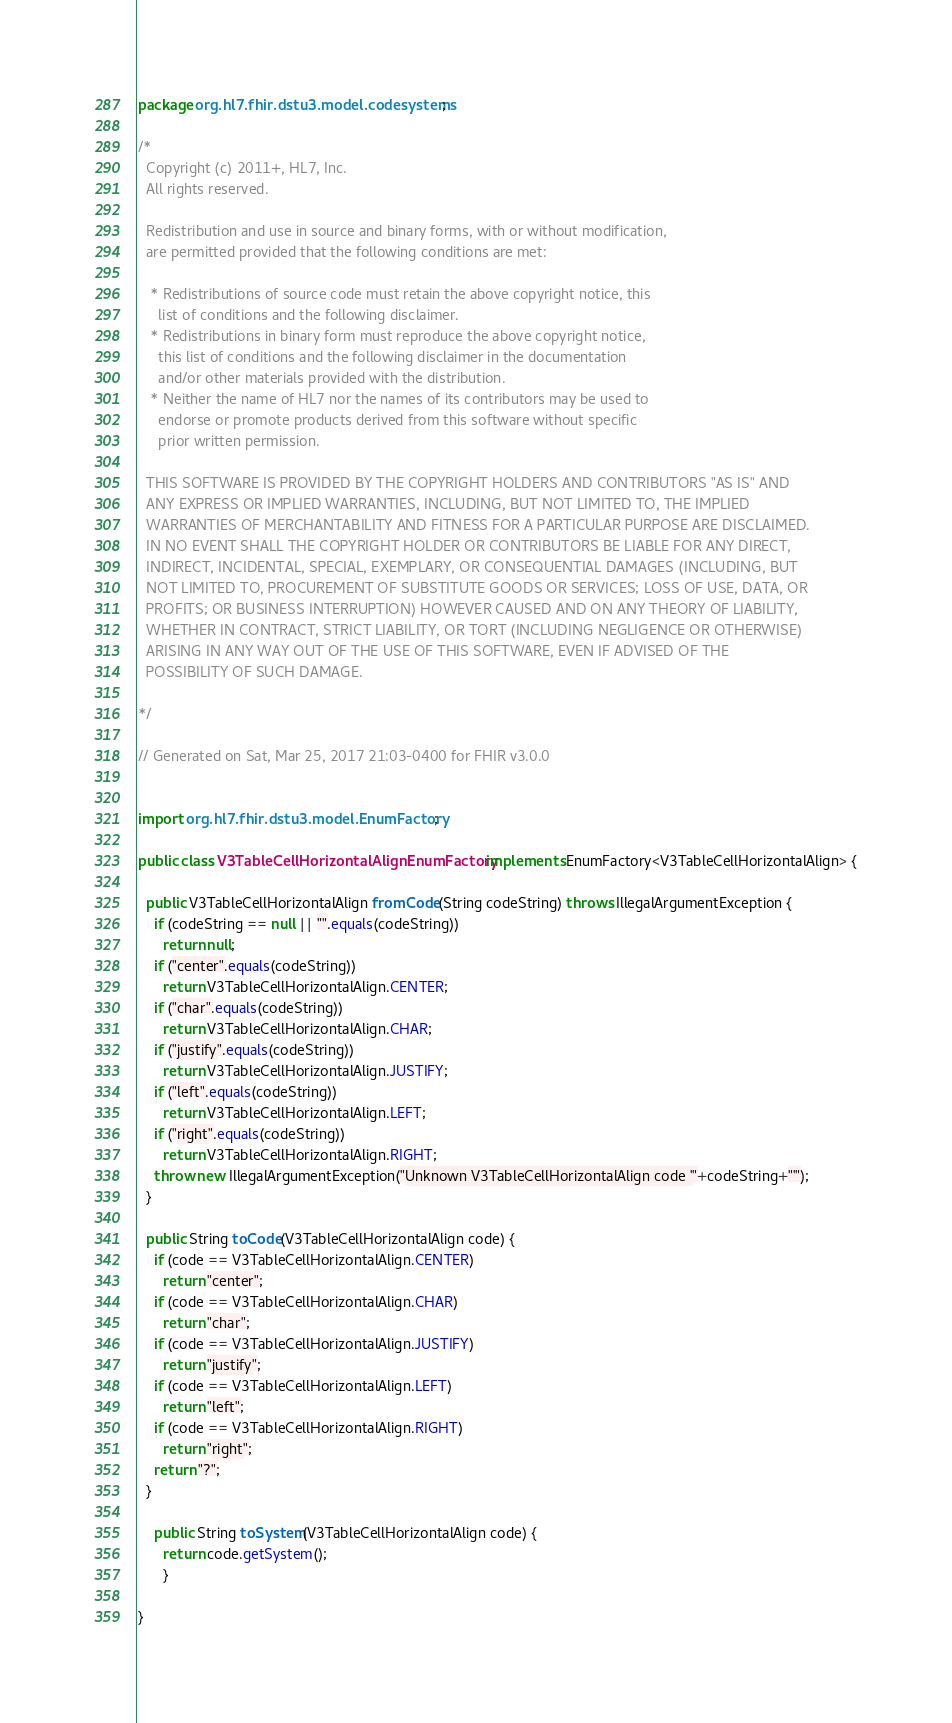Convert code to text. <code><loc_0><loc_0><loc_500><loc_500><_Java_>package org.hl7.fhir.dstu3.model.codesystems;

/*
  Copyright (c) 2011+, HL7, Inc.
  All rights reserved.
  
  Redistribution and use in source and binary forms, with or without modification, 
  are permitted provided that the following conditions are met:
  
   * Redistributions of source code must retain the above copyright notice, this 
     list of conditions and the following disclaimer.
   * Redistributions in binary form must reproduce the above copyright notice, 
     this list of conditions and the following disclaimer in the documentation 
     and/or other materials provided with the distribution.
   * Neither the name of HL7 nor the names of its contributors may be used to 
     endorse or promote products derived from this software without specific 
     prior written permission.
  
  THIS SOFTWARE IS PROVIDED BY THE COPYRIGHT HOLDERS AND CONTRIBUTORS "AS IS" AND 
  ANY EXPRESS OR IMPLIED WARRANTIES, INCLUDING, BUT NOT LIMITED TO, THE IMPLIED 
  WARRANTIES OF MERCHANTABILITY AND FITNESS FOR A PARTICULAR PURPOSE ARE DISCLAIMED. 
  IN NO EVENT SHALL THE COPYRIGHT HOLDER OR CONTRIBUTORS BE LIABLE FOR ANY DIRECT, 
  INDIRECT, INCIDENTAL, SPECIAL, EXEMPLARY, OR CONSEQUENTIAL DAMAGES (INCLUDING, BUT 
  NOT LIMITED TO, PROCUREMENT OF SUBSTITUTE GOODS OR SERVICES; LOSS OF USE, DATA, OR 
  PROFITS; OR BUSINESS INTERRUPTION) HOWEVER CAUSED AND ON ANY THEORY OF LIABILITY, 
  WHETHER IN CONTRACT, STRICT LIABILITY, OR TORT (INCLUDING NEGLIGENCE OR OTHERWISE) 
  ARISING IN ANY WAY OUT OF THE USE OF THIS SOFTWARE, EVEN IF ADVISED OF THE 
  POSSIBILITY OF SUCH DAMAGE.
  
*/

// Generated on Sat, Mar 25, 2017 21:03-0400 for FHIR v3.0.0


import org.hl7.fhir.dstu3.model.EnumFactory;

public class V3TableCellHorizontalAlignEnumFactory implements EnumFactory<V3TableCellHorizontalAlign> {

  public V3TableCellHorizontalAlign fromCode(String codeString) throws IllegalArgumentException {
    if (codeString == null || "".equals(codeString))
      return null;
    if ("center".equals(codeString))
      return V3TableCellHorizontalAlign.CENTER;
    if ("char".equals(codeString))
      return V3TableCellHorizontalAlign.CHAR;
    if ("justify".equals(codeString))
      return V3TableCellHorizontalAlign.JUSTIFY;
    if ("left".equals(codeString))
      return V3TableCellHorizontalAlign.LEFT;
    if ("right".equals(codeString))
      return V3TableCellHorizontalAlign.RIGHT;
    throw new IllegalArgumentException("Unknown V3TableCellHorizontalAlign code '"+codeString+"'");
  }

  public String toCode(V3TableCellHorizontalAlign code) {
    if (code == V3TableCellHorizontalAlign.CENTER)
      return "center";
    if (code == V3TableCellHorizontalAlign.CHAR)
      return "char";
    if (code == V3TableCellHorizontalAlign.JUSTIFY)
      return "justify";
    if (code == V3TableCellHorizontalAlign.LEFT)
      return "left";
    if (code == V3TableCellHorizontalAlign.RIGHT)
      return "right";
    return "?";
  }

    public String toSystem(V3TableCellHorizontalAlign code) {
      return code.getSystem();
      }

}

</code> 